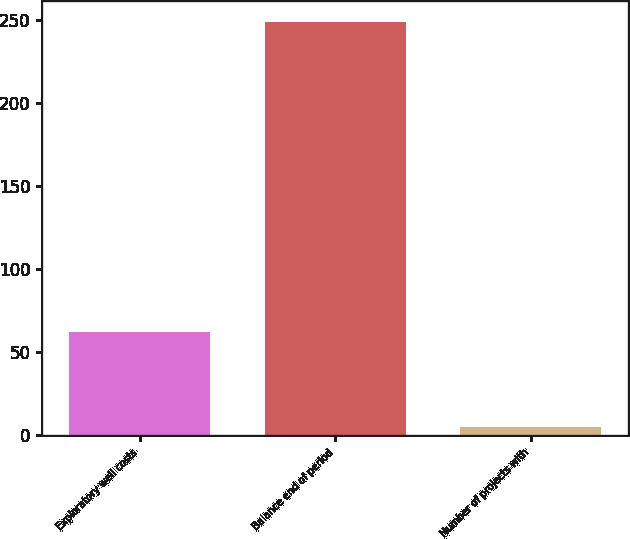Convert chart to OTSL. <chart><loc_0><loc_0><loc_500><loc_500><bar_chart><fcel>Exploratory well costs<fcel>Balance end of period<fcel>Number of projects with<nl><fcel>62<fcel>249<fcel>5<nl></chart> 